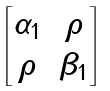Convert formula to latex. <formula><loc_0><loc_0><loc_500><loc_500>\begin{bmatrix} \alpha _ { 1 } & \rho \\ \rho & \beta _ { 1 } \end{bmatrix}</formula> 